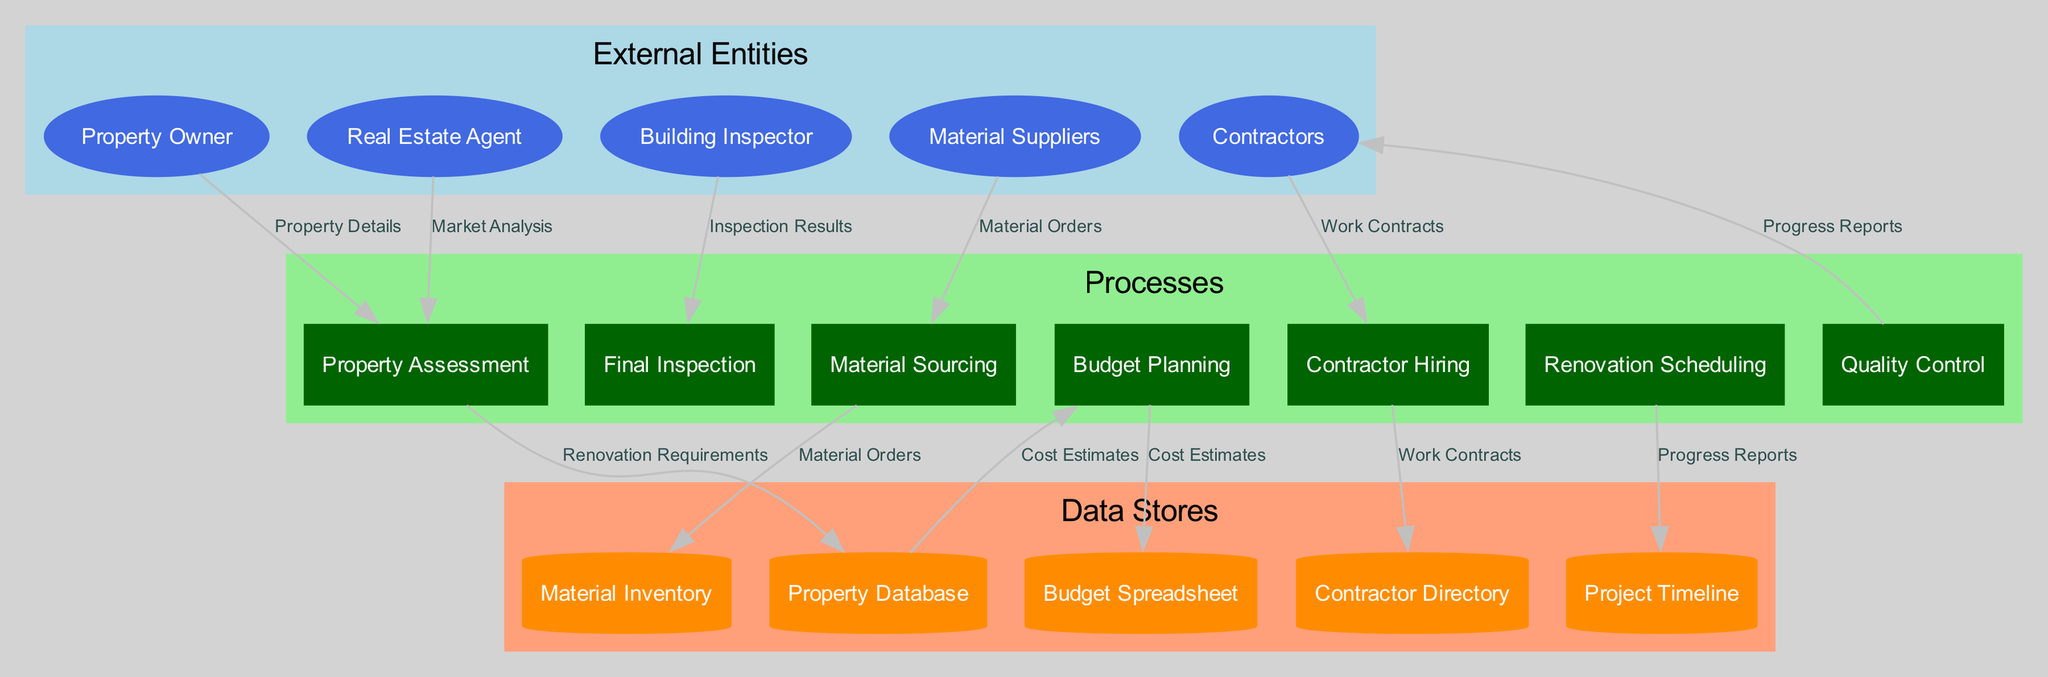What are the external entities involved in the renovation project? The diagram identifies five external entities: Property Owner, Real Estate Agent, Building Inspector, Material Suppliers, and Contractors. These entities interact with processes throughout the workflow.
Answer: Property Owner, Real Estate Agent, Building Inspector, Material Suppliers, Contractors How many processes are included in the diagram? The diagram outlines seven distinct processes for the renovation project management workflow: Property Assessment, Budget Planning, Material Sourcing, Contractor Hiring, Renovation Scheduling, Quality Control, and Final Inspection. Counting these processes provides the total.
Answer: seven What data flow connects the Property Owner to the Property Assessment process? According to the diagram, the data flow named "Property Details" connects the Property Owner to the Property Assessment process. This indicates that the property owner provides necessary information for assessment.
Answer: Property Details Which data store is updated after the Property Assessment process? The diagram indicates that the Property Database gets updated after the Property Assessment process, capturing important information such as Renovation Requirements. This shows the importance of the Property Assessment in informing subsequent stages.
Answer: Property Database What is the final process in the renovation project workflow? The last process in the renovation project management workflow, as depicted in the diagram, is Final Inspection. This marks the end of the project where a thorough inspection is conducted to ensure quality and compliance with standards.
Answer: Final Inspection What type of relationship exists between Quality Control and Contractors? The diagram illustrates that a flow of "Progress Reports" exists from Quality Control to Contractors, indicating a feedback loop where quality assurance informs contractors on project progress and any adjustments needed.
Answer: Progress Reports How many data stores are mentioned in the diagram? There are five data stores referenced in the diagram: Property Database, Budget Spreadsheet, Material Inventory, Contractor Directory, and Project Timeline. Counting these provides the total number of data stores in the renovation workflow.
Answer: five Which external entity is connected to the Final Inspection process? The diagram indicates that the Building Inspector is the external entity connected to the Final Inspection process, showing their role in verifying compliance and quality of the renovation project.
Answer: Building Inspector 